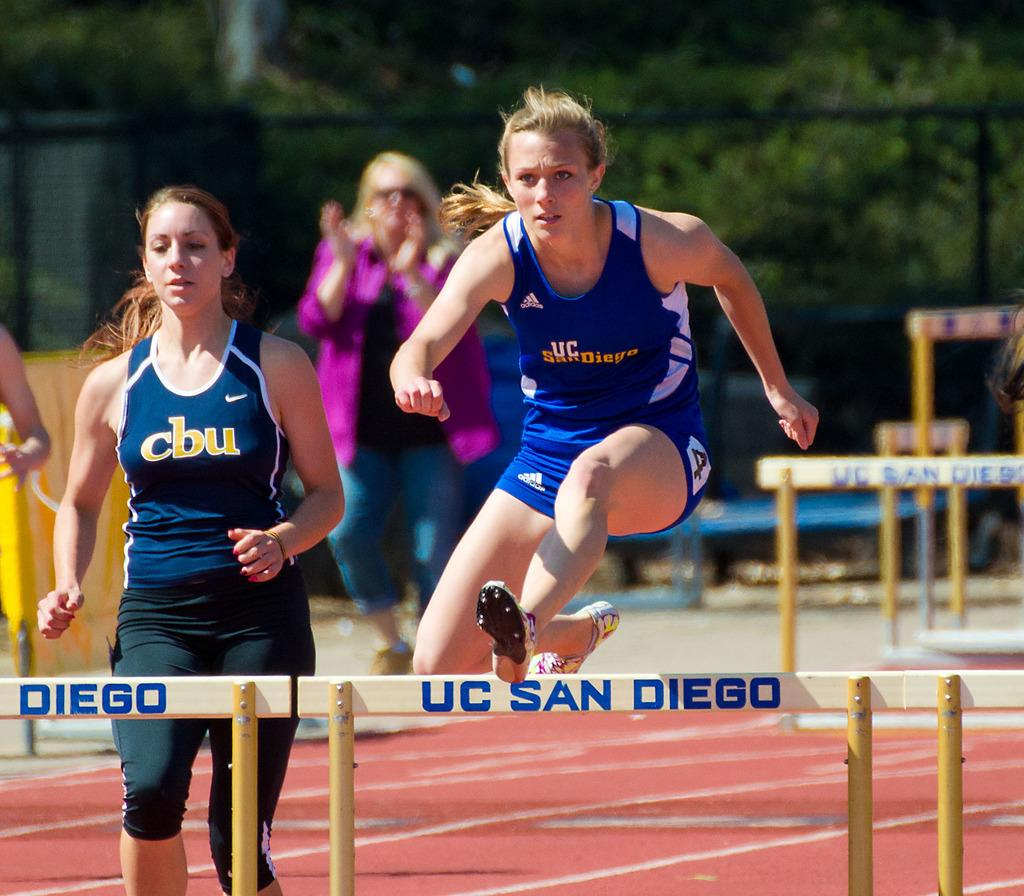<image>
Create a compact narrative representing the image presented. A runner jumps over a hurdle that says UC San Diego on it. 